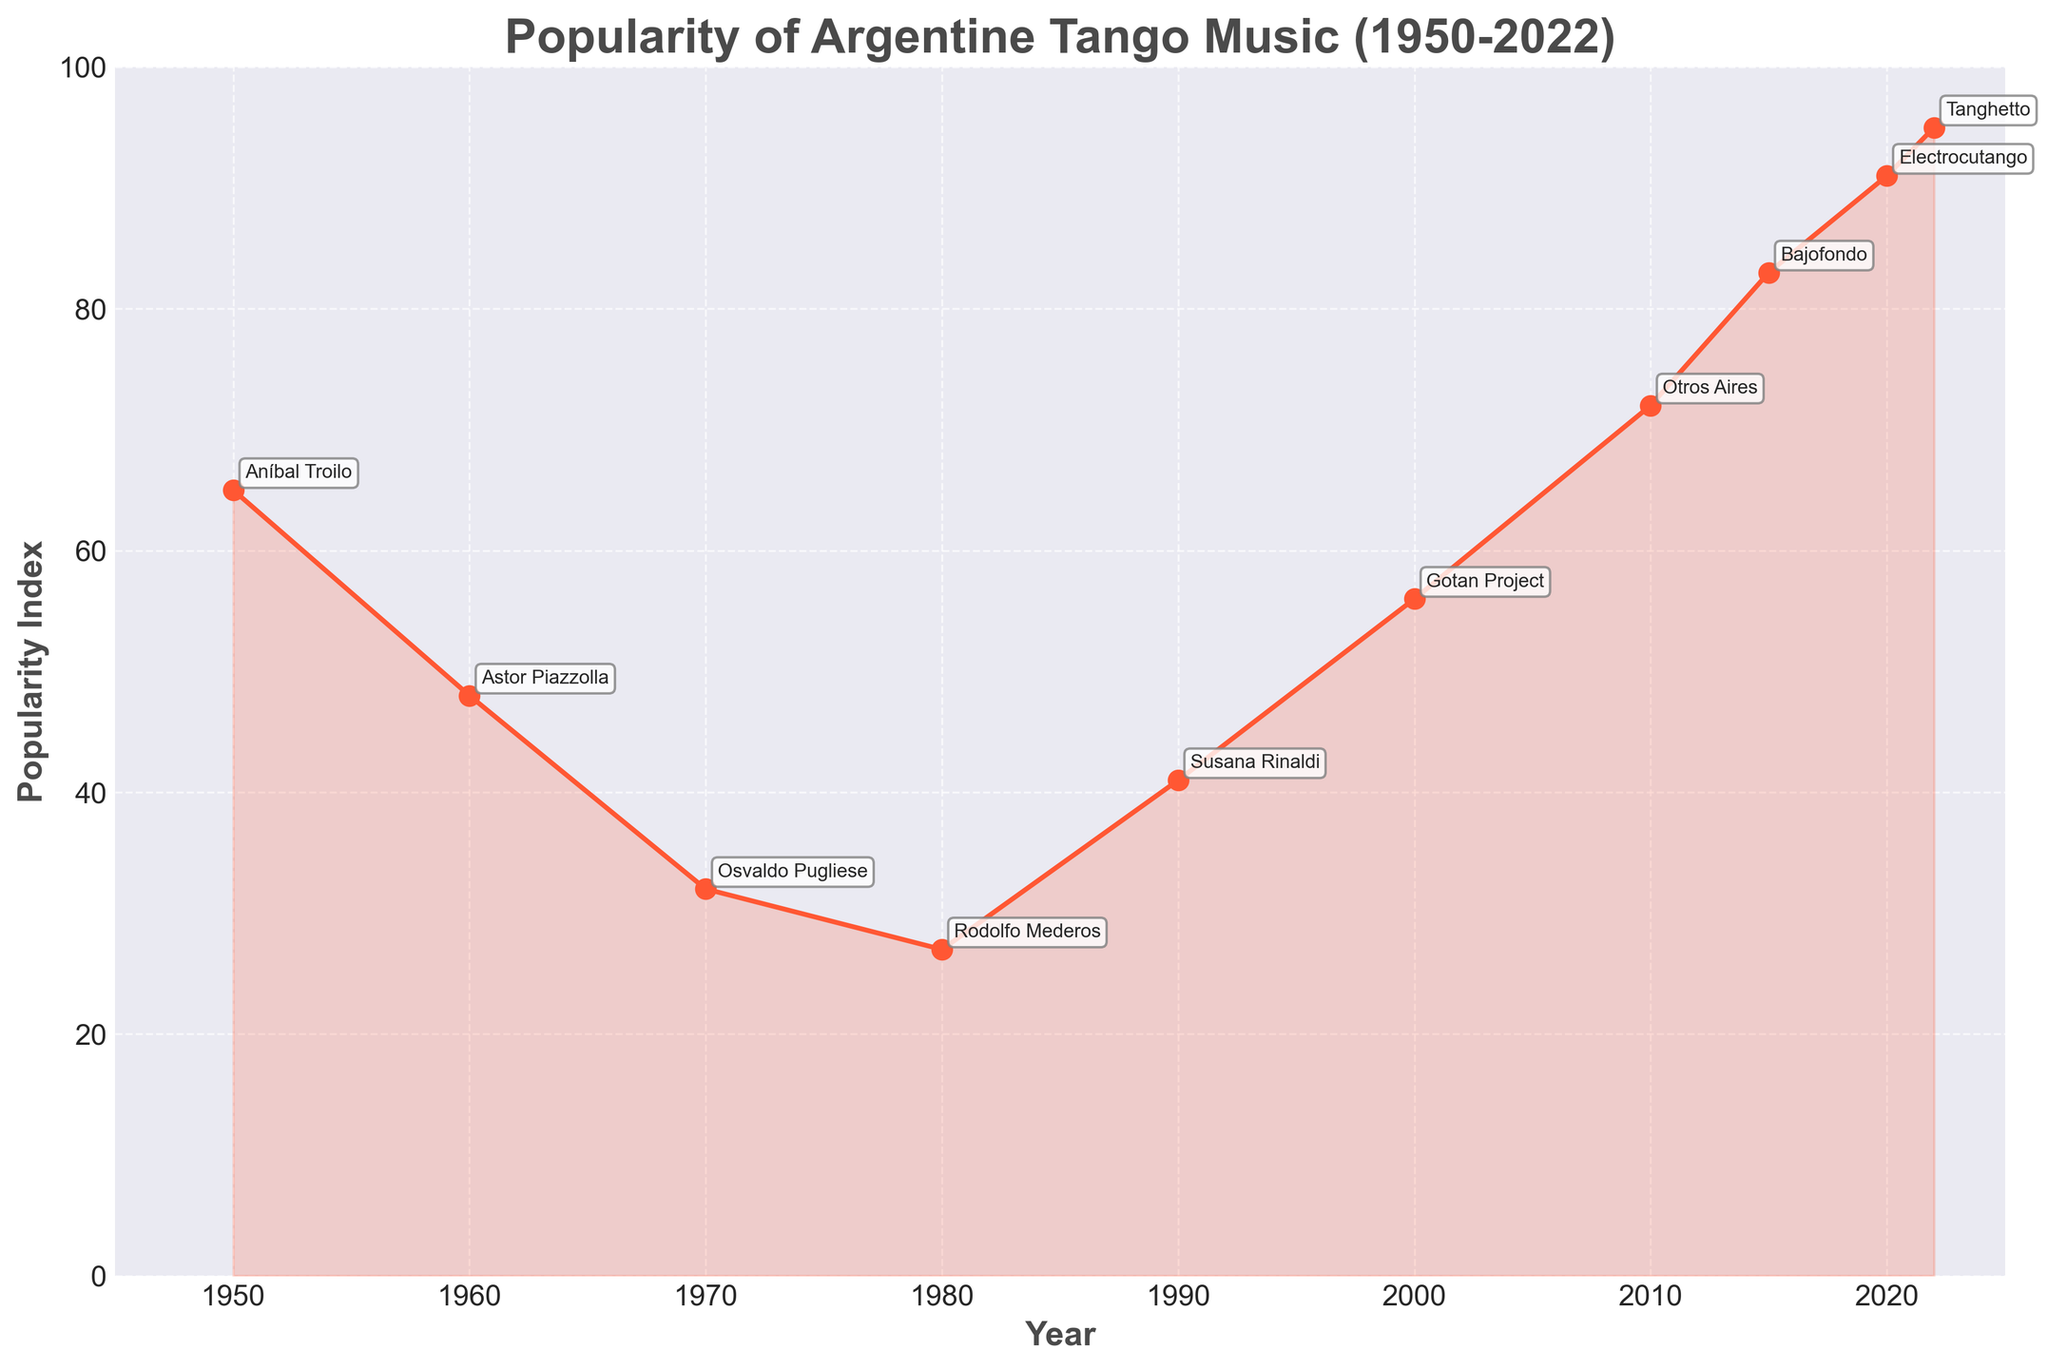What year had the lowest popularity index, and what was the index value then? The line chart shows a low point in popularity around the year 1980. To determine the exact year and the corresponding index value, refer to the labeled data points. 1980 had a popularity index of 27.
Answer: 1980, 27 How did the popularity of Tango music change between the year 1950 and the year 2000? To find the change in popularity, compare the index values for 1950 and 2000. The popularity index was 65 in 1950 and 56 in 2000. Find the difference between these two values. The difference is 65 - 56 = 9.
Answer: It decreased by 9 Which artist was at the top during the global revival of Tango music in 2010? Look at the label for the year 2010 on the chart. The top artist for that year is indicated next to the data point. The name next to 2010 is Otros Aires.
Answer: Otros Aires Between the years 1970 and 2022, what was the overall trend in the popularity of Argentine Tango music? Observe the trend line from 1970 to 2022. The line shows an initial decline followed by a steady increase, peaking in recent years. The overall trend was a recovery and growth in popularity.
Answer: Increasing Which years had major increases in the popularity index by at least 20 points compared to the previous data point? Identify years where the popularity index increased by at least 20 points compared to the previous year by checking the labeled values. From 1980 to 1990, the index increased from 27 to 41 (14 points), which is insufficient. From 2000 to 2010, the increase was 56 to 72 (16 points), also insufficient. From 2015 to 2020, the increase was 83 to 91 (8 points), also insufficient. No years had an increase of at least 20 points.
Answer: None 